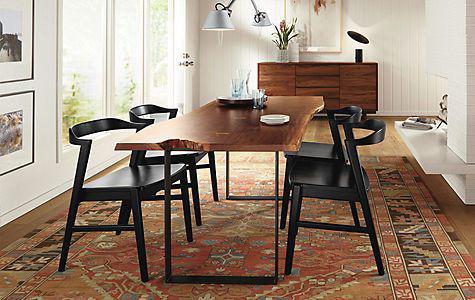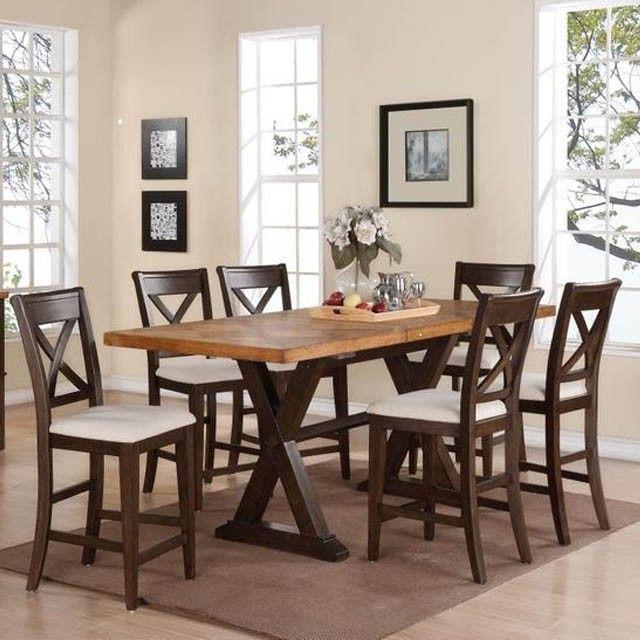The first image is the image on the left, the second image is the image on the right. Examine the images to the left and right. Is the description "One long table is shown with four chairs and one with six chairs." accurate? Answer yes or no. Yes. 